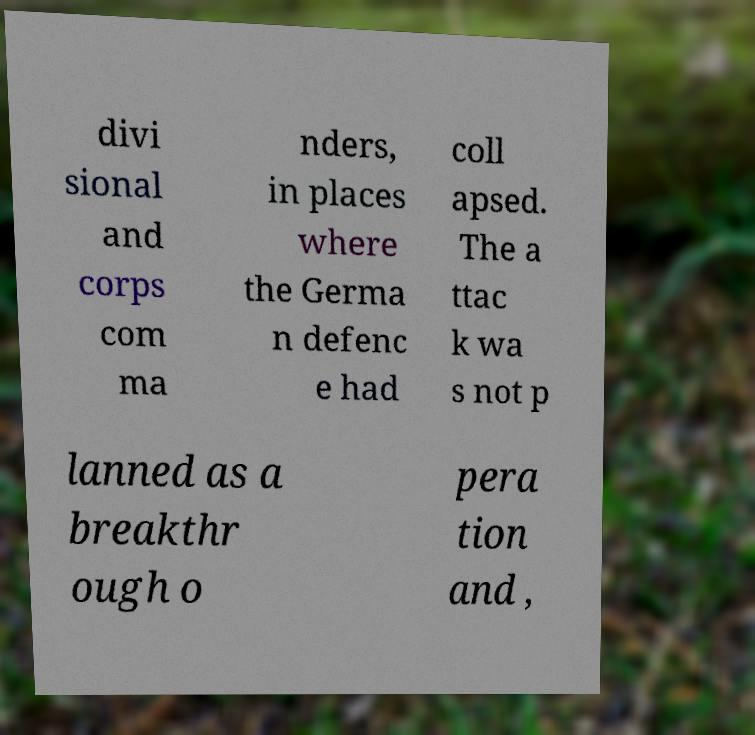Please identify and transcribe the text found in this image. divi sional and corps com ma nders, in places where the Germa n defenc e had coll apsed. The a ttac k wa s not p lanned as a breakthr ough o pera tion and , 